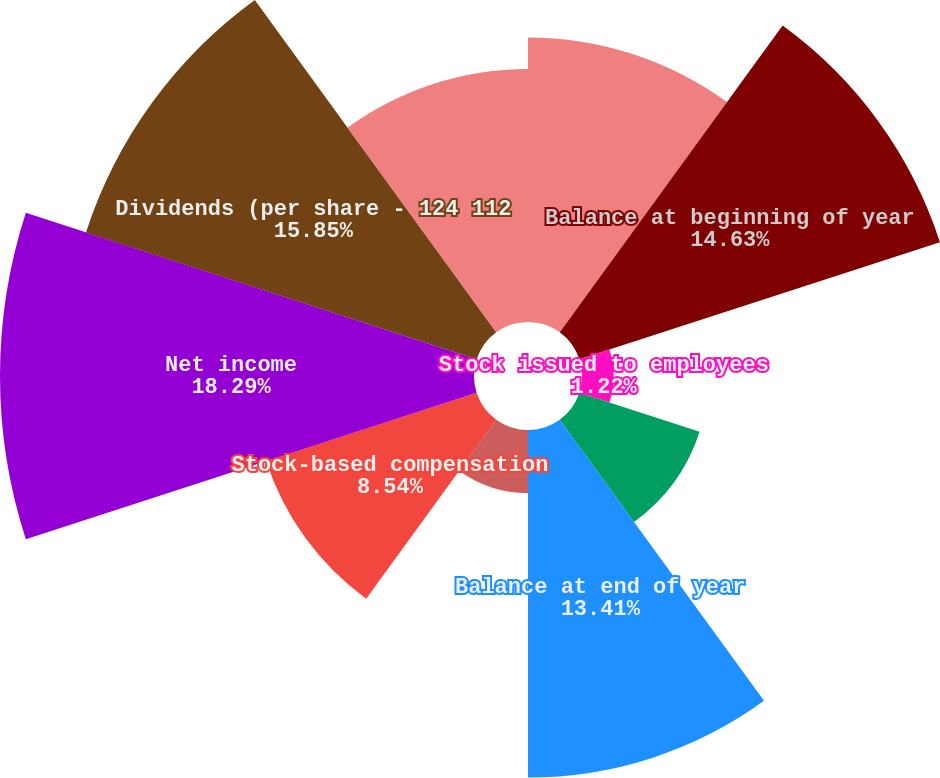<chart> <loc_0><loc_0><loc_500><loc_500><pie_chart><fcel>Year Ended December 31<fcel>Balance at beginning of year<fcel>Stock issued to employees<fcel>Purchases of stock for<fcel>Balance at end of year<fcel>Tax benefit from employees'<fcel>Stock-based compensation<fcel>Net income<fcel>Dividends (per share - 124 112<fcel>Net foreign currency<nl><fcel>10.98%<fcel>14.63%<fcel>1.22%<fcel>4.88%<fcel>13.41%<fcel>2.44%<fcel>8.54%<fcel>18.29%<fcel>15.85%<fcel>9.76%<nl></chart> 